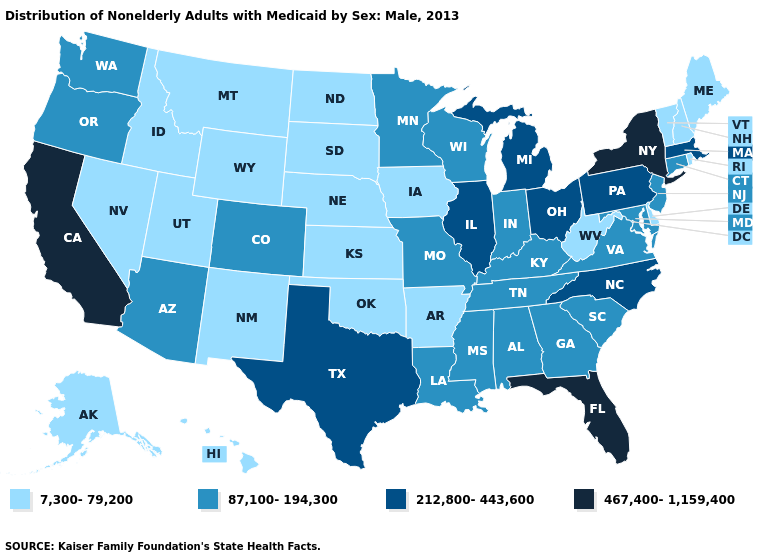Name the states that have a value in the range 467,400-1,159,400?
Write a very short answer. California, Florida, New York. What is the value of Oklahoma?
Give a very brief answer. 7,300-79,200. What is the value of Virginia?
Be succinct. 87,100-194,300. Name the states that have a value in the range 87,100-194,300?
Keep it brief. Alabama, Arizona, Colorado, Connecticut, Georgia, Indiana, Kentucky, Louisiana, Maryland, Minnesota, Mississippi, Missouri, New Jersey, Oregon, South Carolina, Tennessee, Virginia, Washington, Wisconsin. What is the lowest value in the USA?
Concise answer only. 7,300-79,200. Name the states that have a value in the range 7,300-79,200?
Write a very short answer. Alaska, Arkansas, Delaware, Hawaii, Idaho, Iowa, Kansas, Maine, Montana, Nebraska, Nevada, New Hampshire, New Mexico, North Dakota, Oklahoma, Rhode Island, South Dakota, Utah, Vermont, West Virginia, Wyoming. What is the value of Maryland?
Quick response, please. 87,100-194,300. Which states have the lowest value in the USA?
Concise answer only. Alaska, Arkansas, Delaware, Hawaii, Idaho, Iowa, Kansas, Maine, Montana, Nebraska, Nevada, New Hampshire, New Mexico, North Dakota, Oklahoma, Rhode Island, South Dakota, Utah, Vermont, West Virginia, Wyoming. What is the highest value in the USA?
Short answer required. 467,400-1,159,400. How many symbols are there in the legend?
Keep it brief. 4. Name the states that have a value in the range 87,100-194,300?
Answer briefly. Alabama, Arizona, Colorado, Connecticut, Georgia, Indiana, Kentucky, Louisiana, Maryland, Minnesota, Mississippi, Missouri, New Jersey, Oregon, South Carolina, Tennessee, Virginia, Washington, Wisconsin. Name the states that have a value in the range 7,300-79,200?
Quick response, please. Alaska, Arkansas, Delaware, Hawaii, Idaho, Iowa, Kansas, Maine, Montana, Nebraska, Nevada, New Hampshire, New Mexico, North Dakota, Oklahoma, Rhode Island, South Dakota, Utah, Vermont, West Virginia, Wyoming. Among the states that border Massachusetts , does New York have the lowest value?
Answer briefly. No. Which states have the lowest value in the USA?
Give a very brief answer. Alaska, Arkansas, Delaware, Hawaii, Idaho, Iowa, Kansas, Maine, Montana, Nebraska, Nevada, New Hampshire, New Mexico, North Dakota, Oklahoma, Rhode Island, South Dakota, Utah, Vermont, West Virginia, Wyoming. Does the map have missing data?
Short answer required. No. 